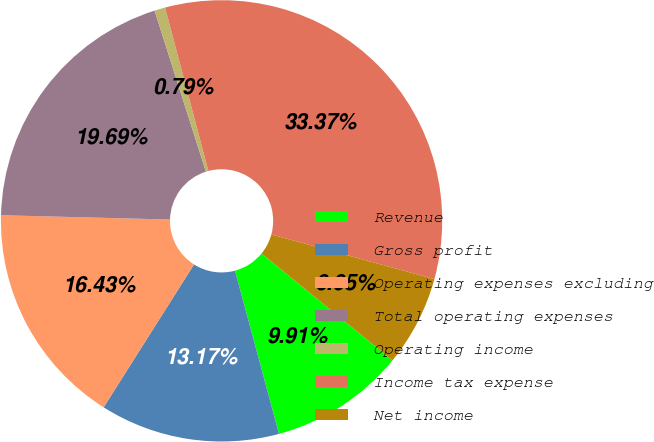Convert chart to OTSL. <chart><loc_0><loc_0><loc_500><loc_500><pie_chart><fcel>Revenue<fcel>Gross profit<fcel>Operating expenses excluding<fcel>Total operating expenses<fcel>Operating income<fcel>Income tax expense<fcel>Net income<nl><fcel>9.91%<fcel>13.17%<fcel>16.43%<fcel>19.69%<fcel>0.79%<fcel>33.38%<fcel>6.65%<nl></chart> 